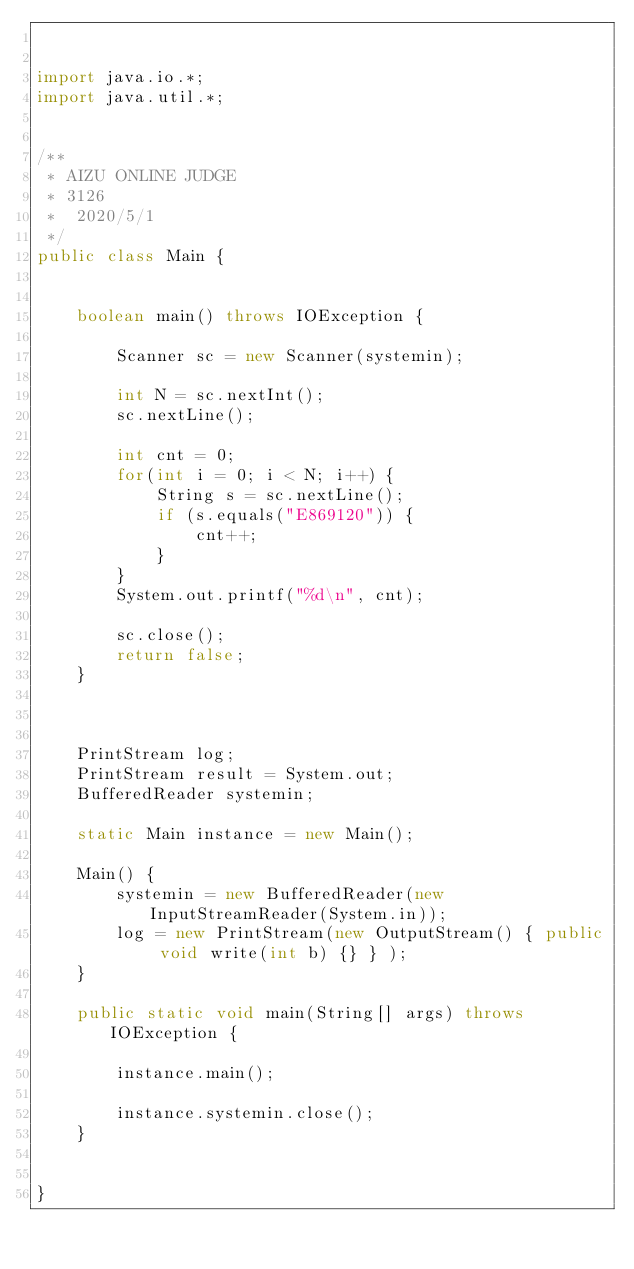Convert code to text. <code><loc_0><loc_0><loc_500><loc_500><_Java_>

import java.io.*;
import java.util.*;


/**
 * AIZU ONLINE JUDGE
 * 3126
 *  2020/5/1
 */
public class Main {


    boolean main() throws IOException {

        Scanner sc = new Scanner(systemin);

        int N = sc.nextInt();
        sc.nextLine();

        int cnt = 0;
        for(int i = 0; i < N; i++) {
            String s = sc.nextLine();
            if (s.equals("E869120")) {
                cnt++;
            }
        }
        System.out.printf("%d\n", cnt);

        sc.close();
        return false;
    }



    PrintStream log;
    PrintStream result = System.out;
    BufferedReader systemin;

    static Main instance = new Main();

    Main() {
        systemin = new BufferedReader(new InputStreamReader(System.in));
        log = new PrintStream(new OutputStream() { public void write(int b) {} } );
    }

    public static void main(String[] args) throws IOException {

        instance.main();

        instance.systemin.close();
    }


}


</code> 